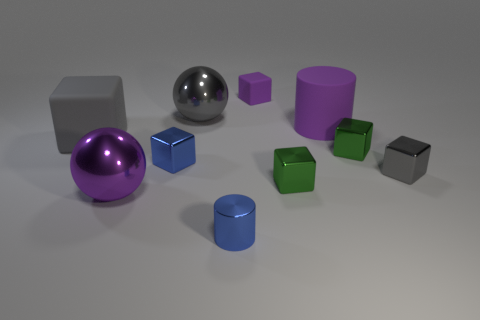Subtract all blue cubes. How many cubes are left? 5 Subtract all brown cylinders. How many gray blocks are left? 2 Subtract all purple blocks. How many blocks are left? 5 Subtract all yellow cubes. Subtract all gray cylinders. How many cubes are left? 6 Add 4 blue cylinders. How many blue cylinders are left? 5 Add 4 matte cubes. How many matte cubes exist? 6 Subtract 1 gray spheres. How many objects are left? 9 Subtract all cylinders. How many objects are left? 8 Subtract all small metal cylinders. Subtract all tiny objects. How many objects are left? 3 